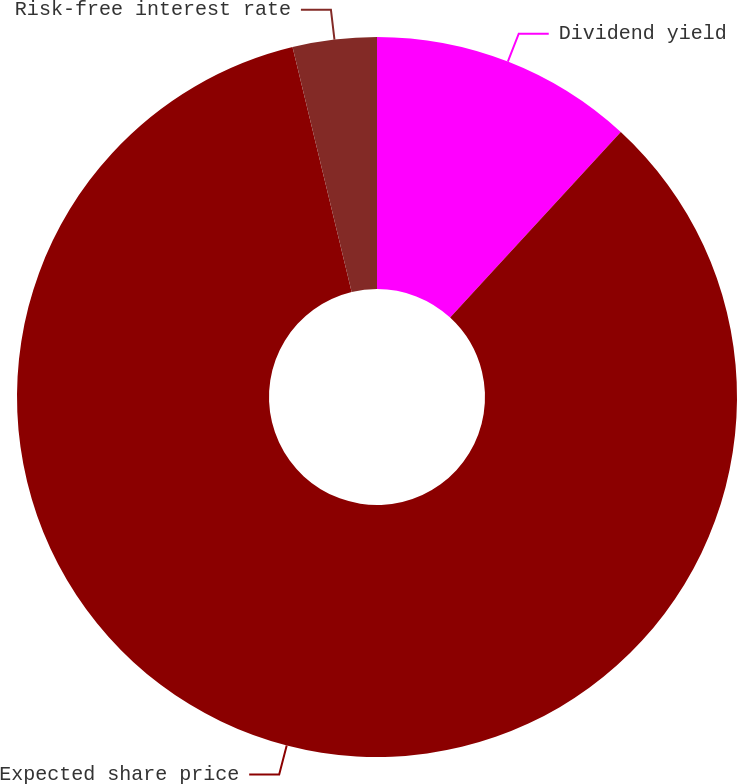Convert chart to OTSL. <chart><loc_0><loc_0><loc_500><loc_500><pie_chart><fcel>Dividend yield<fcel>Expected share price<fcel>Risk-free interest rate<nl><fcel>11.84%<fcel>84.39%<fcel>3.77%<nl></chart> 